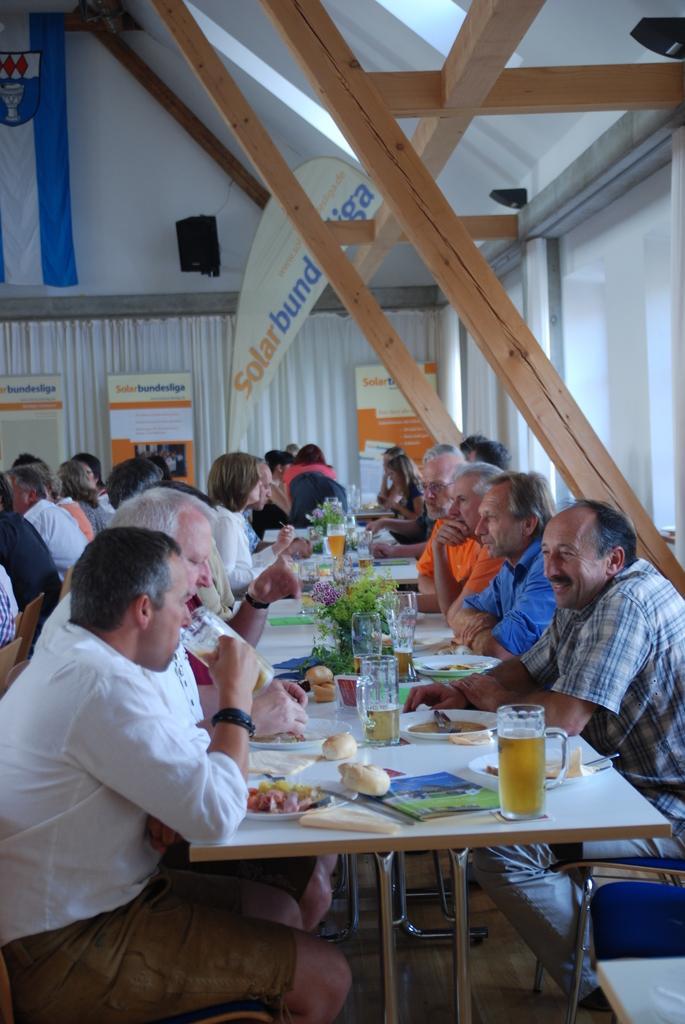Describe this image in one or two sentences. There are many people sitting in this room. There is a table. And on this table there is a book, bun, plate food items, flower vase, glasses, spoons. A person is wearing white shirt and a brown trousers is drinking. Behind it there is a curtain and some posters are over there. 